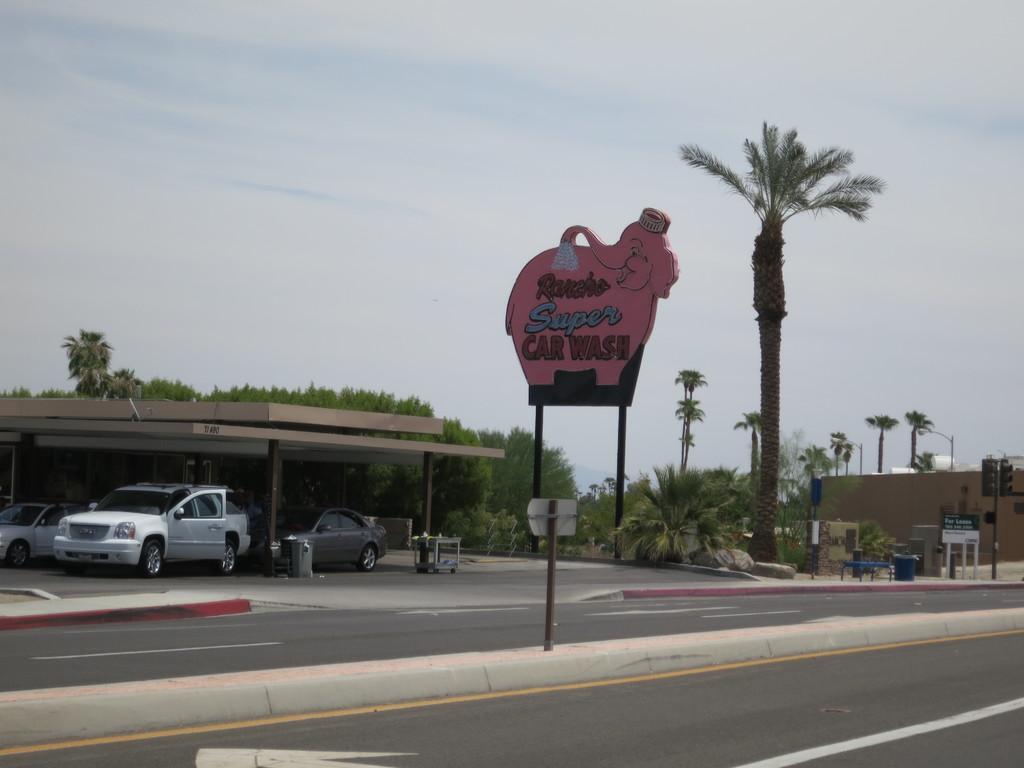How would you summarize this image in a sentence or two? In this image at front there is a road. On the backside there are cars parked under the building. Beside the car there is a dustbin. In the background there is a board with the name written on it. We can also see traffic signals, trees, buildings and at the top there is sky. 